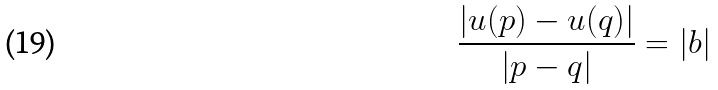<formula> <loc_0><loc_0><loc_500><loc_500>\frac { | u ( p ) - u ( q ) | } { | p - q | } = | b |</formula> 